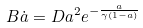Convert formula to latex. <formula><loc_0><loc_0><loc_500><loc_500>B \dot { a } = D a ^ { 2 } e ^ { - \frac { a } { \gamma ( 1 - a ) } }</formula> 